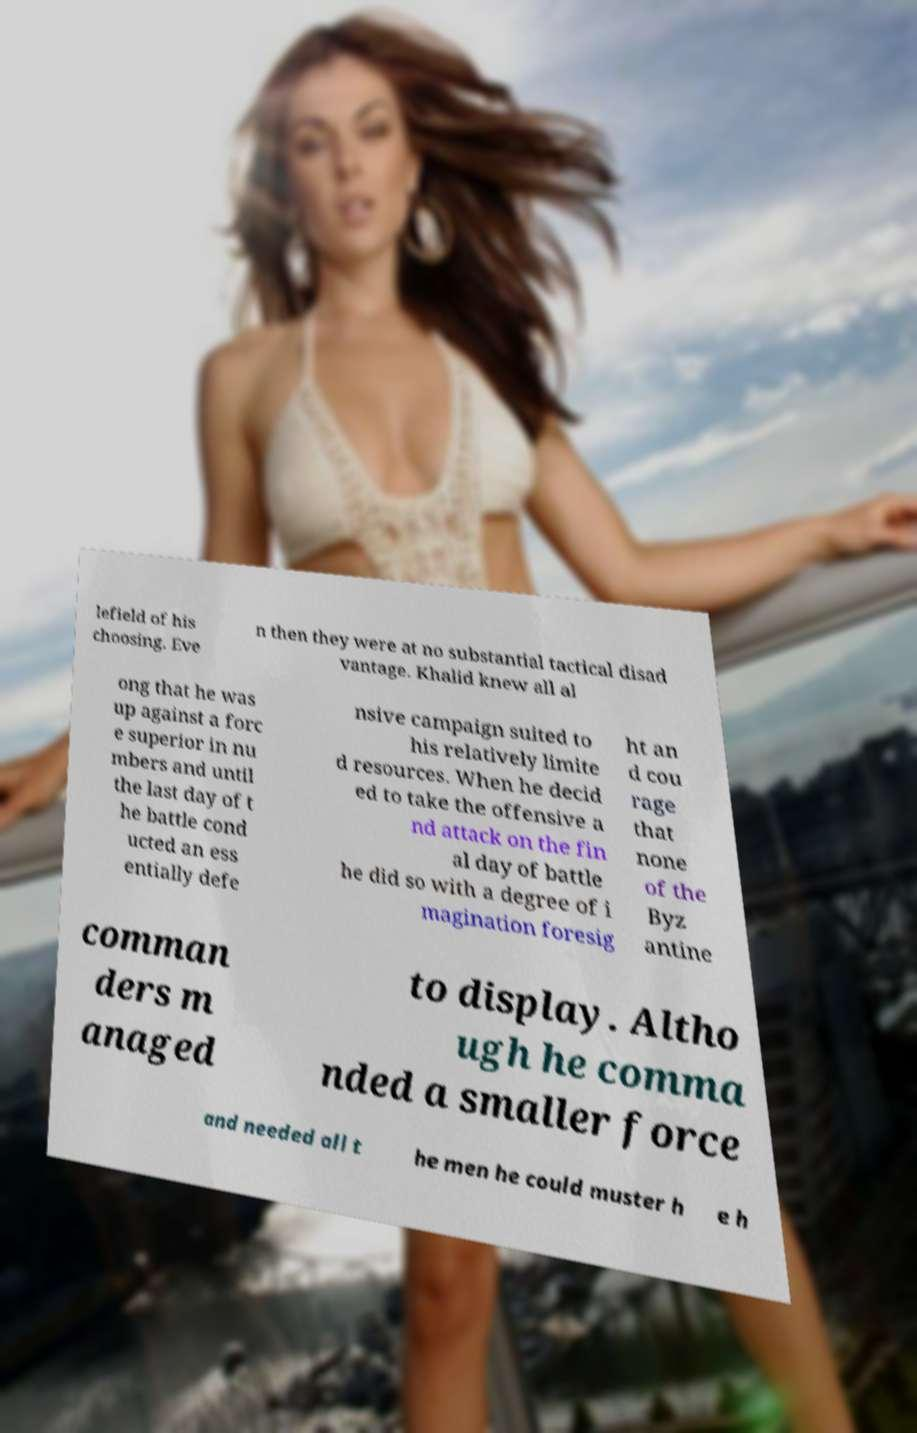Could you assist in decoding the text presented in this image and type it out clearly? lefield of his choosing. Eve n then they were at no substantial tactical disad vantage. Khalid knew all al ong that he was up against a forc e superior in nu mbers and until the last day of t he battle cond ucted an ess entially defe nsive campaign suited to his relatively limite d resources. When he decid ed to take the offensive a nd attack on the fin al day of battle he did so with a degree of i magination foresig ht an d cou rage that none of the Byz antine comman ders m anaged to display. Altho ugh he comma nded a smaller force and needed all t he men he could muster h e h 